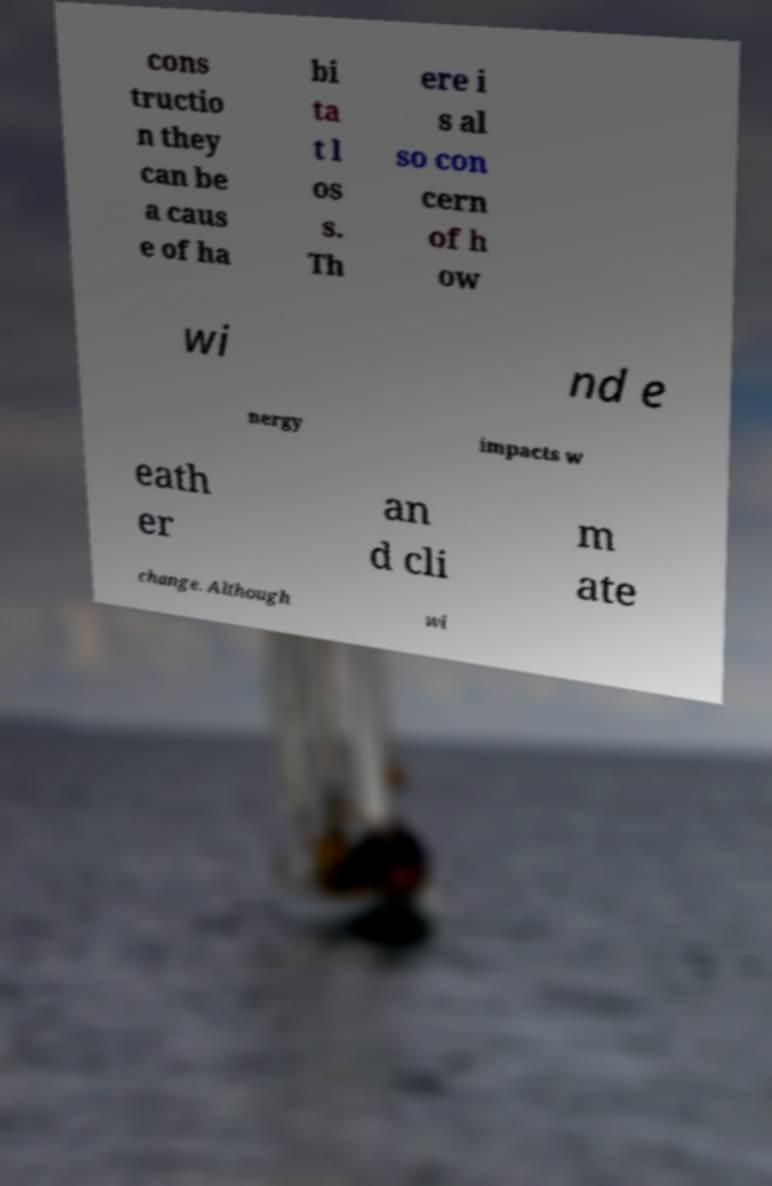What messages or text are displayed in this image? I need them in a readable, typed format. cons tructio n they can be a caus e of ha bi ta t l os s. Th ere i s al so con cern of h ow wi nd e nergy impacts w eath er an d cli m ate change. Although wi 